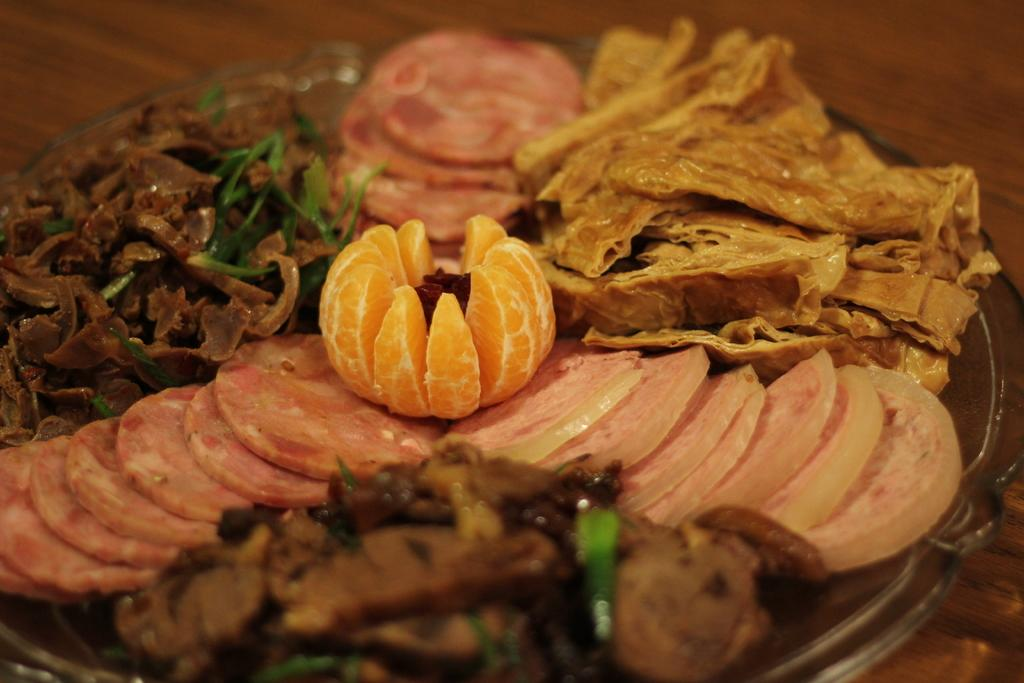What is in the bowl that is visible in the image? There is a bowl containing food in the image. Where is the bowl located in the image? The bowl is placed on a table. What is the name of the mist that is present in the image? There is no mist present in the image; it only features a bowl containing food placed on a table. 